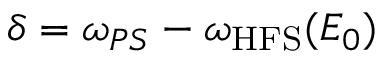<formula> <loc_0><loc_0><loc_500><loc_500>\delta = \omega _ { P S } - \omega _ { H F S } ( E _ { 0 } )</formula> 